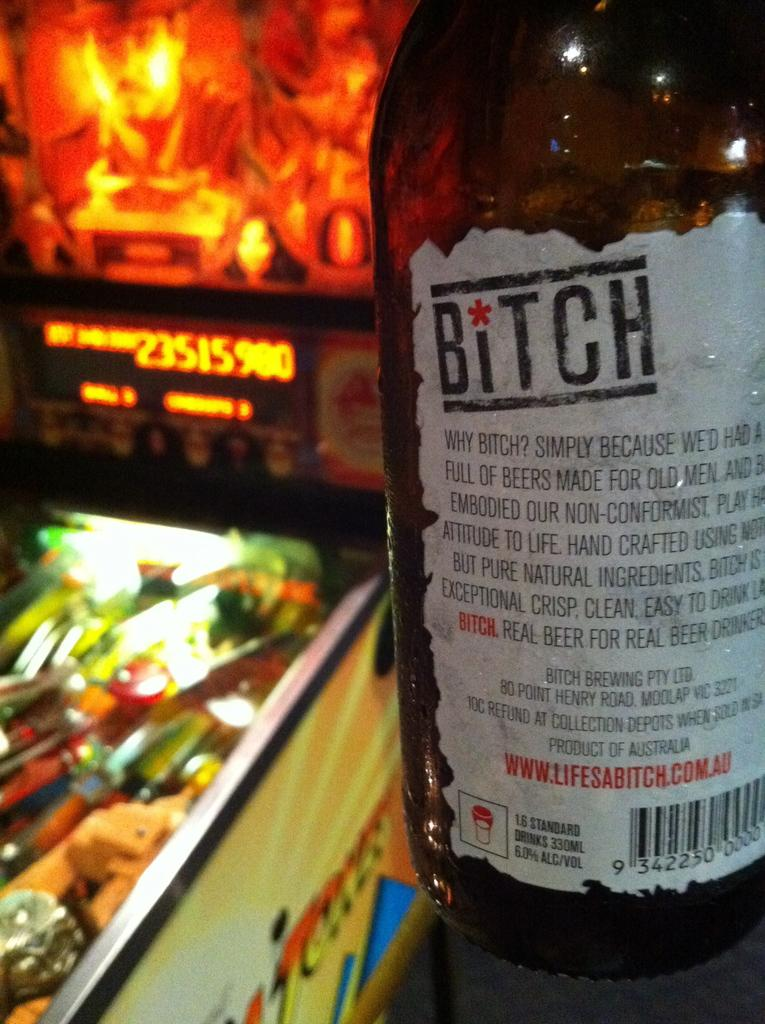<image>
Render a clear and concise summary of the photo. a bottle that is sitting in front of a game with numbers 23515900 on the screen 